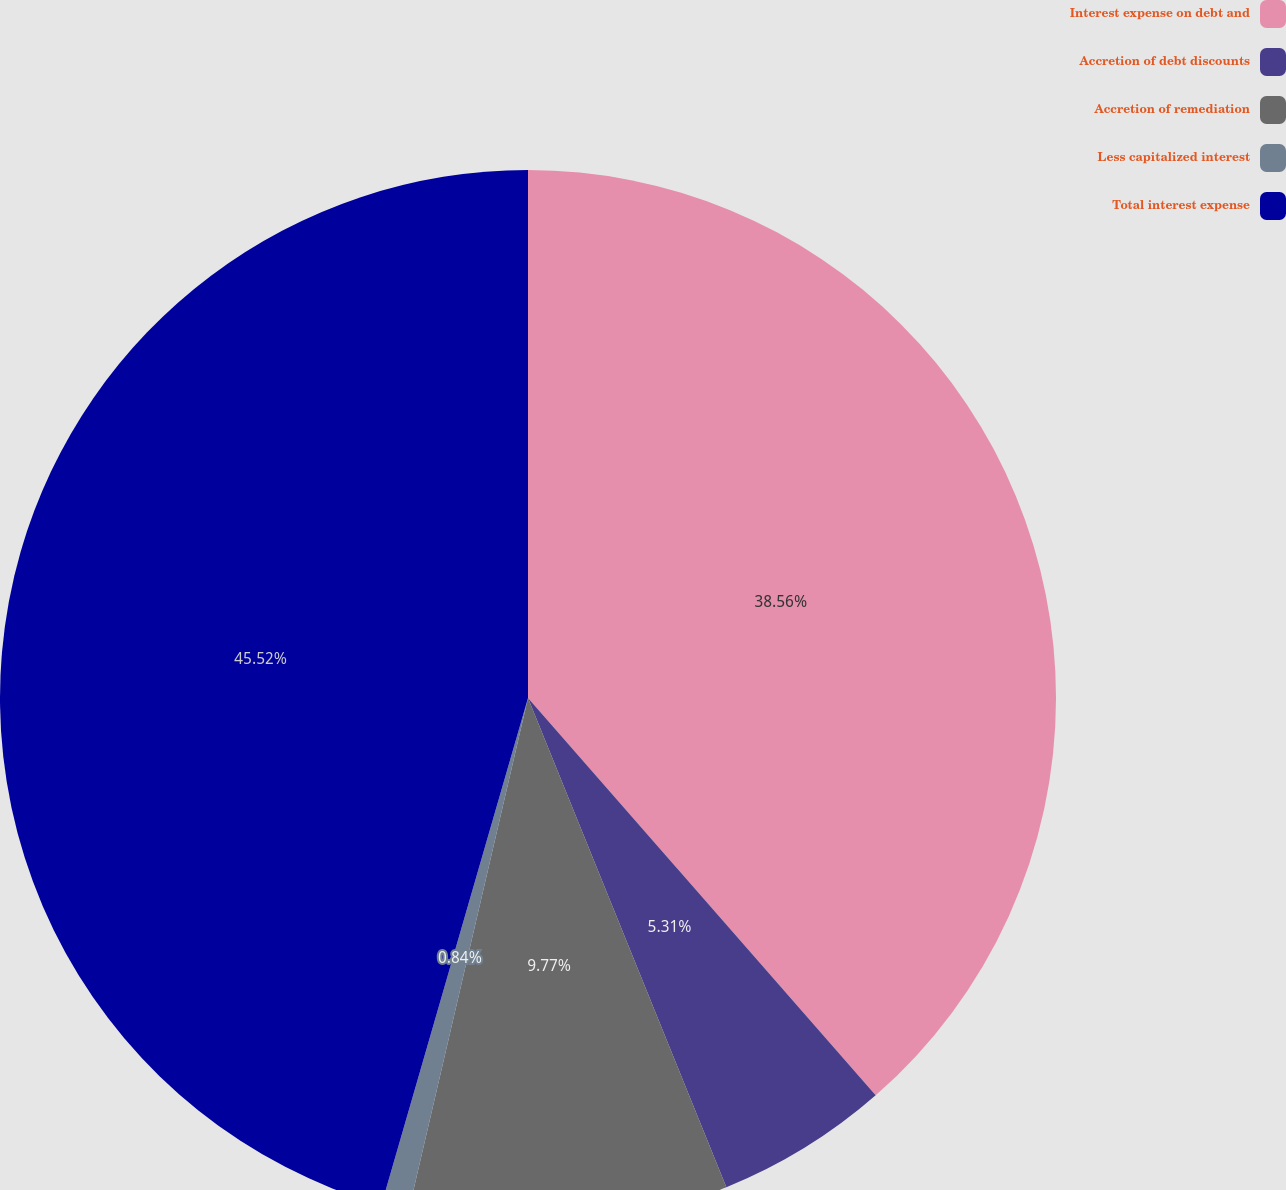Convert chart. <chart><loc_0><loc_0><loc_500><loc_500><pie_chart><fcel>Interest expense on debt and<fcel>Accretion of debt discounts<fcel>Accretion of remediation<fcel>Less capitalized interest<fcel>Total interest expense<nl><fcel>38.56%<fcel>5.31%<fcel>9.77%<fcel>0.84%<fcel>45.52%<nl></chart> 